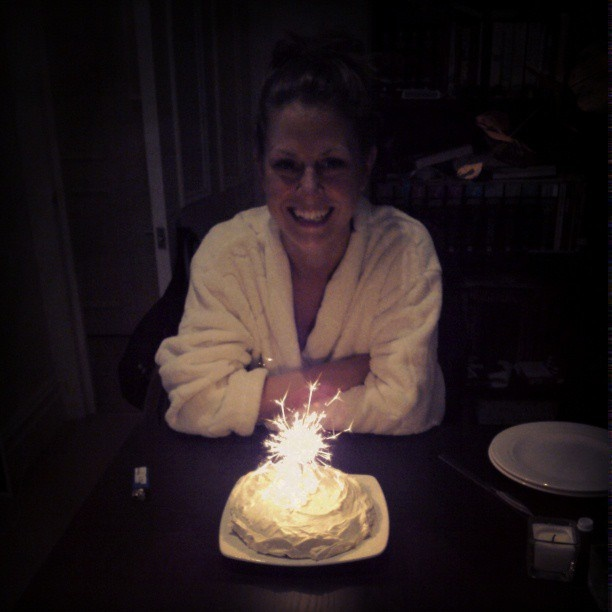Describe the objects in this image and their specific colors. I can see people in black, gray, and brown tones, cake in black, khaki, beige, tan, and gray tones, and knife in black tones in this image. 